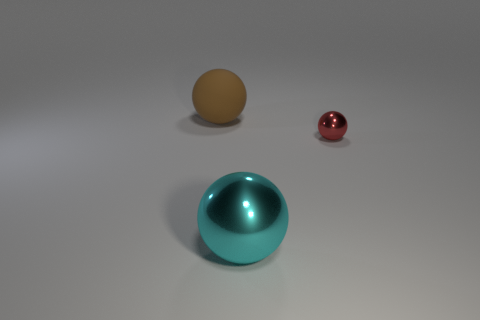Add 3 large shiny balls. How many objects exist? 6 Subtract all big brown rubber objects. Subtract all big cyan shiny objects. How many objects are left? 1 Add 2 big cyan balls. How many big cyan balls are left? 3 Add 3 tiny shiny objects. How many tiny shiny objects exist? 4 Subtract 0 blue blocks. How many objects are left? 3 